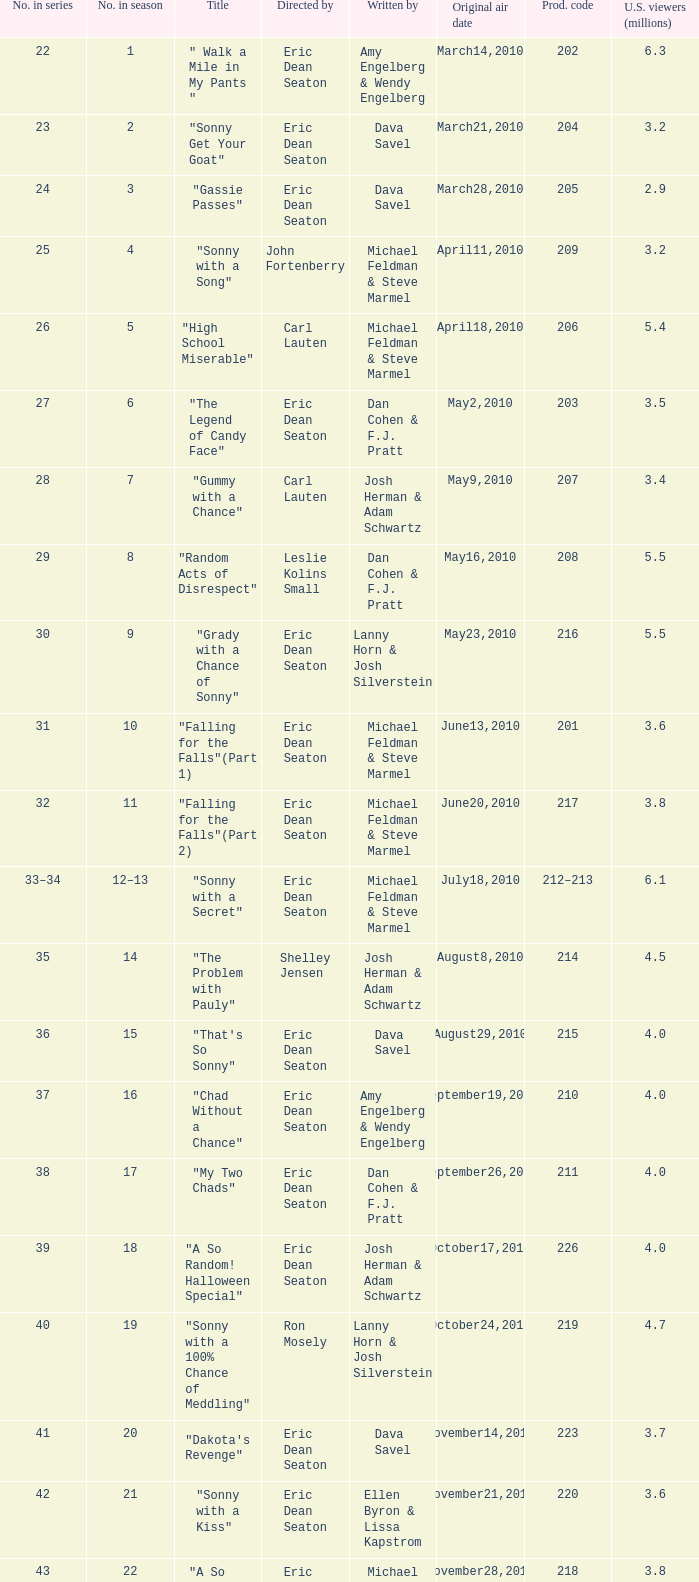What number of episodes in the season were called "that's so sonny"? 1.0. 